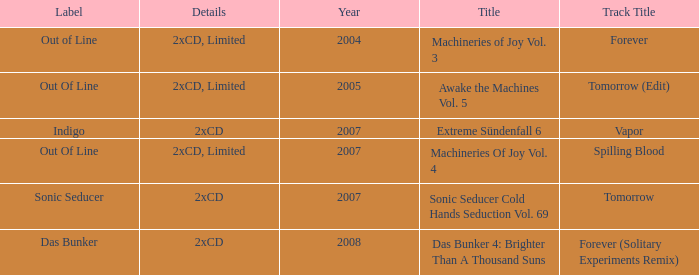Which details has the out of line label and the year of 2005? 2xCD, Limited. 